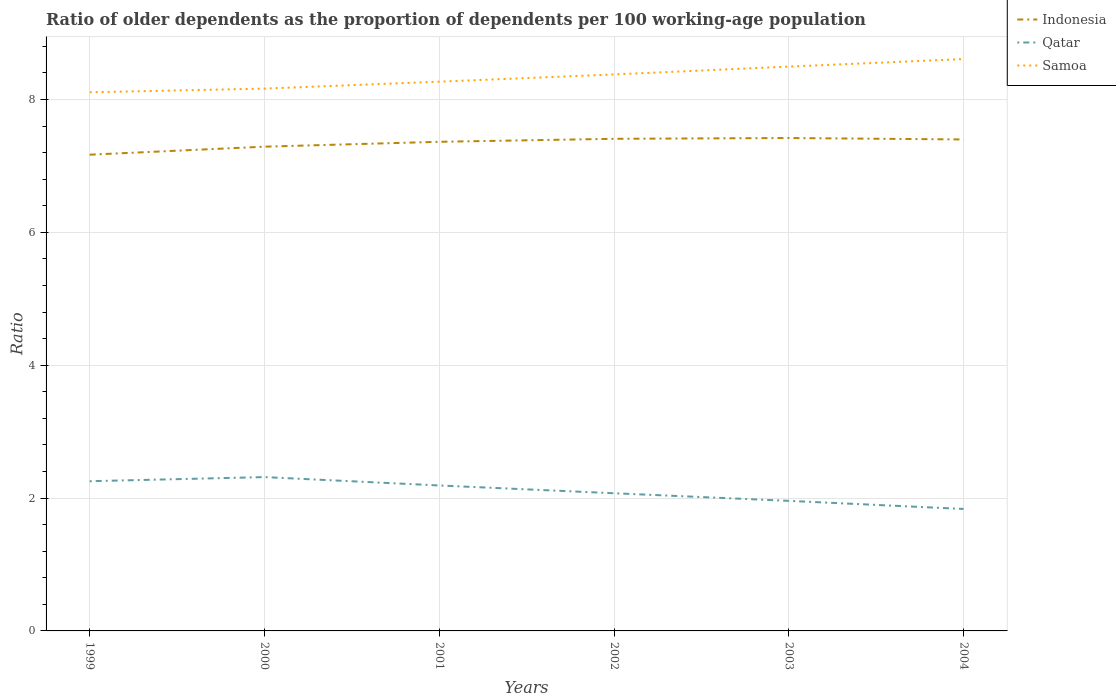Is the number of lines equal to the number of legend labels?
Your answer should be compact. Yes. Across all years, what is the maximum age dependency ratio(old) in Qatar?
Your answer should be compact. 1.84. What is the total age dependency ratio(old) in Indonesia in the graph?
Your answer should be very brief. -0.07. What is the difference between the highest and the second highest age dependency ratio(old) in Qatar?
Give a very brief answer. 0.48. What is the difference between the highest and the lowest age dependency ratio(old) in Samoa?
Offer a terse response. 3. Is the age dependency ratio(old) in Samoa strictly greater than the age dependency ratio(old) in Indonesia over the years?
Provide a succinct answer. No. How many lines are there?
Your answer should be compact. 3. Are the values on the major ticks of Y-axis written in scientific E-notation?
Make the answer very short. No. Does the graph contain grids?
Make the answer very short. Yes. How many legend labels are there?
Ensure brevity in your answer.  3. What is the title of the graph?
Ensure brevity in your answer.  Ratio of older dependents as the proportion of dependents per 100 working-age population. What is the label or title of the Y-axis?
Make the answer very short. Ratio. What is the Ratio of Indonesia in 1999?
Keep it short and to the point. 7.17. What is the Ratio of Qatar in 1999?
Your answer should be compact. 2.25. What is the Ratio of Samoa in 1999?
Give a very brief answer. 8.11. What is the Ratio in Indonesia in 2000?
Provide a succinct answer. 7.29. What is the Ratio of Qatar in 2000?
Provide a short and direct response. 2.32. What is the Ratio of Samoa in 2000?
Give a very brief answer. 8.16. What is the Ratio in Indonesia in 2001?
Give a very brief answer. 7.36. What is the Ratio in Qatar in 2001?
Ensure brevity in your answer.  2.19. What is the Ratio of Samoa in 2001?
Your answer should be compact. 8.27. What is the Ratio in Indonesia in 2002?
Offer a terse response. 7.41. What is the Ratio of Qatar in 2002?
Give a very brief answer. 2.07. What is the Ratio of Samoa in 2002?
Provide a short and direct response. 8.38. What is the Ratio in Indonesia in 2003?
Keep it short and to the point. 7.42. What is the Ratio in Qatar in 2003?
Keep it short and to the point. 1.96. What is the Ratio in Samoa in 2003?
Make the answer very short. 8.49. What is the Ratio in Indonesia in 2004?
Offer a very short reply. 7.4. What is the Ratio of Qatar in 2004?
Give a very brief answer. 1.84. What is the Ratio in Samoa in 2004?
Keep it short and to the point. 8.61. Across all years, what is the maximum Ratio of Indonesia?
Ensure brevity in your answer.  7.42. Across all years, what is the maximum Ratio in Qatar?
Offer a very short reply. 2.32. Across all years, what is the maximum Ratio in Samoa?
Provide a short and direct response. 8.61. Across all years, what is the minimum Ratio in Indonesia?
Your answer should be compact. 7.17. Across all years, what is the minimum Ratio in Qatar?
Your answer should be very brief. 1.84. Across all years, what is the minimum Ratio of Samoa?
Your response must be concise. 8.11. What is the total Ratio in Indonesia in the graph?
Keep it short and to the point. 44.05. What is the total Ratio in Qatar in the graph?
Provide a short and direct response. 12.62. What is the total Ratio of Samoa in the graph?
Ensure brevity in your answer.  50.02. What is the difference between the Ratio of Indonesia in 1999 and that in 2000?
Your response must be concise. -0.12. What is the difference between the Ratio of Qatar in 1999 and that in 2000?
Your answer should be compact. -0.06. What is the difference between the Ratio in Samoa in 1999 and that in 2000?
Provide a short and direct response. -0.06. What is the difference between the Ratio of Indonesia in 1999 and that in 2001?
Ensure brevity in your answer.  -0.19. What is the difference between the Ratio in Qatar in 1999 and that in 2001?
Your answer should be compact. 0.06. What is the difference between the Ratio in Samoa in 1999 and that in 2001?
Provide a short and direct response. -0.16. What is the difference between the Ratio of Indonesia in 1999 and that in 2002?
Keep it short and to the point. -0.24. What is the difference between the Ratio of Qatar in 1999 and that in 2002?
Keep it short and to the point. 0.18. What is the difference between the Ratio of Samoa in 1999 and that in 2002?
Make the answer very short. -0.27. What is the difference between the Ratio of Indonesia in 1999 and that in 2003?
Make the answer very short. -0.25. What is the difference between the Ratio of Qatar in 1999 and that in 2003?
Your response must be concise. 0.3. What is the difference between the Ratio in Samoa in 1999 and that in 2003?
Make the answer very short. -0.39. What is the difference between the Ratio in Indonesia in 1999 and that in 2004?
Offer a terse response. -0.23. What is the difference between the Ratio in Qatar in 1999 and that in 2004?
Your response must be concise. 0.42. What is the difference between the Ratio of Samoa in 1999 and that in 2004?
Give a very brief answer. -0.5. What is the difference between the Ratio in Indonesia in 2000 and that in 2001?
Provide a succinct answer. -0.07. What is the difference between the Ratio in Qatar in 2000 and that in 2001?
Provide a succinct answer. 0.13. What is the difference between the Ratio in Samoa in 2000 and that in 2001?
Offer a terse response. -0.1. What is the difference between the Ratio in Indonesia in 2000 and that in 2002?
Your answer should be very brief. -0.12. What is the difference between the Ratio of Qatar in 2000 and that in 2002?
Offer a very short reply. 0.24. What is the difference between the Ratio in Samoa in 2000 and that in 2002?
Give a very brief answer. -0.21. What is the difference between the Ratio of Indonesia in 2000 and that in 2003?
Give a very brief answer. -0.13. What is the difference between the Ratio in Qatar in 2000 and that in 2003?
Ensure brevity in your answer.  0.36. What is the difference between the Ratio in Samoa in 2000 and that in 2003?
Offer a terse response. -0.33. What is the difference between the Ratio in Indonesia in 2000 and that in 2004?
Ensure brevity in your answer.  -0.11. What is the difference between the Ratio of Qatar in 2000 and that in 2004?
Your answer should be very brief. 0.48. What is the difference between the Ratio of Samoa in 2000 and that in 2004?
Give a very brief answer. -0.44. What is the difference between the Ratio in Indonesia in 2001 and that in 2002?
Give a very brief answer. -0.05. What is the difference between the Ratio in Qatar in 2001 and that in 2002?
Your response must be concise. 0.12. What is the difference between the Ratio in Samoa in 2001 and that in 2002?
Ensure brevity in your answer.  -0.11. What is the difference between the Ratio in Indonesia in 2001 and that in 2003?
Ensure brevity in your answer.  -0.06. What is the difference between the Ratio in Qatar in 2001 and that in 2003?
Ensure brevity in your answer.  0.23. What is the difference between the Ratio in Samoa in 2001 and that in 2003?
Your response must be concise. -0.23. What is the difference between the Ratio in Indonesia in 2001 and that in 2004?
Your answer should be very brief. -0.04. What is the difference between the Ratio of Qatar in 2001 and that in 2004?
Make the answer very short. 0.35. What is the difference between the Ratio of Samoa in 2001 and that in 2004?
Offer a terse response. -0.34. What is the difference between the Ratio in Indonesia in 2002 and that in 2003?
Your answer should be compact. -0.01. What is the difference between the Ratio of Qatar in 2002 and that in 2003?
Give a very brief answer. 0.11. What is the difference between the Ratio in Samoa in 2002 and that in 2003?
Provide a short and direct response. -0.12. What is the difference between the Ratio in Indonesia in 2002 and that in 2004?
Your answer should be compact. 0.01. What is the difference between the Ratio in Qatar in 2002 and that in 2004?
Provide a succinct answer. 0.24. What is the difference between the Ratio in Samoa in 2002 and that in 2004?
Offer a very short reply. -0.23. What is the difference between the Ratio in Indonesia in 2003 and that in 2004?
Give a very brief answer. 0.02. What is the difference between the Ratio in Qatar in 2003 and that in 2004?
Provide a short and direct response. 0.12. What is the difference between the Ratio of Samoa in 2003 and that in 2004?
Ensure brevity in your answer.  -0.11. What is the difference between the Ratio of Indonesia in 1999 and the Ratio of Qatar in 2000?
Your response must be concise. 4.85. What is the difference between the Ratio of Indonesia in 1999 and the Ratio of Samoa in 2000?
Offer a very short reply. -0.99. What is the difference between the Ratio of Qatar in 1999 and the Ratio of Samoa in 2000?
Offer a very short reply. -5.91. What is the difference between the Ratio of Indonesia in 1999 and the Ratio of Qatar in 2001?
Ensure brevity in your answer.  4.98. What is the difference between the Ratio of Indonesia in 1999 and the Ratio of Samoa in 2001?
Provide a short and direct response. -1.1. What is the difference between the Ratio in Qatar in 1999 and the Ratio in Samoa in 2001?
Keep it short and to the point. -6.01. What is the difference between the Ratio of Indonesia in 1999 and the Ratio of Qatar in 2002?
Your response must be concise. 5.1. What is the difference between the Ratio of Indonesia in 1999 and the Ratio of Samoa in 2002?
Your answer should be very brief. -1.21. What is the difference between the Ratio of Qatar in 1999 and the Ratio of Samoa in 2002?
Your answer should be compact. -6.12. What is the difference between the Ratio in Indonesia in 1999 and the Ratio in Qatar in 2003?
Make the answer very short. 5.21. What is the difference between the Ratio in Indonesia in 1999 and the Ratio in Samoa in 2003?
Ensure brevity in your answer.  -1.33. What is the difference between the Ratio in Qatar in 1999 and the Ratio in Samoa in 2003?
Provide a succinct answer. -6.24. What is the difference between the Ratio of Indonesia in 1999 and the Ratio of Qatar in 2004?
Keep it short and to the point. 5.33. What is the difference between the Ratio in Indonesia in 1999 and the Ratio in Samoa in 2004?
Offer a terse response. -1.44. What is the difference between the Ratio of Qatar in 1999 and the Ratio of Samoa in 2004?
Ensure brevity in your answer.  -6.35. What is the difference between the Ratio of Indonesia in 2000 and the Ratio of Qatar in 2001?
Your response must be concise. 5.1. What is the difference between the Ratio in Indonesia in 2000 and the Ratio in Samoa in 2001?
Your answer should be very brief. -0.98. What is the difference between the Ratio in Qatar in 2000 and the Ratio in Samoa in 2001?
Keep it short and to the point. -5.95. What is the difference between the Ratio in Indonesia in 2000 and the Ratio in Qatar in 2002?
Your answer should be compact. 5.22. What is the difference between the Ratio of Indonesia in 2000 and the Ratio of Samoa in 2002?
Offer a terse response. -1.09. What is the difference between the Ratio in Qatar in 2000 and the Ratio in Samoa in 2002?
Provide a succinct answer. -6.06. What is the difference between the Ratio of Indonesia in 2000 and the Ratio of Qatar in 2003?
Provide a succinct answer. 5.33. What is the difference between the Ratio in Indonesia in 2000 and the Ratio in Samoa in 2003?
Your answer should be very brief. -1.21. What is the difference between the Ratio of Qatar in 2000 and the Ratio of Samoa in 2003?
Provide a succinct answer. -6.18. What is the difference between the Ratio of Indonesia in 2000 and the Ratio of Qatar in 2004?
Your response must be concise. 5.45. What is the difference between the Ratio of Indonesia in 2000 and the Ratio of Samoa in 2004?
Give a very brief answer. -1.32. What is the difference between the Ratio in Qatar in 2000 and the Ratio in Samoa in 2004?
Make the answer very short. -6.29. What is the difference between the Ratio in Indonesia in 2001 and the Ratio in Qatar in 2002?
Ensure brevity in your answer.  5.29. What is the difference between the Ratio in Indonesia in 2001 and the Ratio in Samoa in 2002?
Provide a succinct answer. -1.01. What is the difference between the Ratio of Qatar in 2001 and the Ratio of Samoa in 2002?
Provide a short and direct response. -6.19. What is the difference between the Ratio of Indonesia in 2001 and the Ratio of Qatar in 2003?
Ensure brevity in your answer.  5.4. What is the difference between the Ratio in Indonesia in 2001 and the Ratio in Samoa in 2003?
Provide a succinct answer. -1.13. What is the difference between the Ratio in Qatar in 2001 and the Ratio in Samoa in 2003?
Ensure brevity in your answer.  -6.31. What is the difference between the Ratio in Indonesia in 2001 and the Ratio in Qatar in 2004?
Provide a succinct answer. 5.53. What is the difference between the Ratio in Indonesia in 2001 and the Ratio in Samoa in 2004?
Offer a terse response. -1.25. What is the difference between the Ratio of Qatar in 2001 and the Ratio of Samoa in 2004?
Provide a short and direct response. -6.42. What is the difference between the Ratio in Indonesia in 2002 and the Ratio in Qatar in 2003?
Your answer should be very brief. 5.45. What is the difference between the Ratio of Indonesia in 2002 and the Ratio of Samoa in 2003?
Keep it short and to the point. -1.09. What is the difference between the Ratio of Qatar in 2002 and the Ratio of Samoa in 2003?
Offer a very short reply. -6.42. What is the difference between the Ratio in Indonesia in 2002 and the Ratio in Qatar in 2004?
Your response must be concise. 5.57. What is the difference between the Ratio in Indonesia in 2002 and the Ratio in Samoa in 2004?
Keep it short and to the point. -1.2. What is the difference between the Ratio of Qatar in 2002 and the Ratio of Samoa in 2004?
Offer a terse response. -6.54. What is the difference between the Ratio in Indonesia in 2003 and the Ratio in Qatar in 2004?
Ensure brevity in your answer.  5.58. What is the difference between the Ratio in Indonesia in 2003 and the Ratio in Samoa in 2004?
Provide a short and direct response. -1.19. What is the difference between the Ratio in Qatar in 2003 and the Ratio in Samoa in 2004?
Offer a terse response. -6.65. What is the average Ratio in Indonesia per year?
Make the answer very short. 7.34. What is the average Ratio of Qatar per year?
Provide a short and direct response. 2.1. What is the average Ratio of Samoa per year?
Offer a very short reply. 8.34. In the year 1999, what is the difference between the Ratio of Indonesia and Ratio of Qatar?
Keep it short and to the point. 4.92. In the year 1999, what is the difference between the Ratio of Indonesia and Ratio of Samoa?
Your response must be concise. -0.94. In the year 1999, what is the difference between the Ratio in Qatar and Ratio in Samoa?
Ensure brevity in your answer.  -5.85. In the year 2000, what is the difference between the Ratio of Indonesia and Ratio of Qatar?
Ensure brevity in your answer.  4.97. In the year 2000, what is the difference between the Ratio of Indonesia and Ratio of Samoa?
Keep it short and to the point. -0.87. In the year 2000, what is the difference between the Ratio of Qatar and Ratio of Samoa?
Your answer should be compact. -5.85. In the year 2001, what is the difference between the Ratio in Indonesia and Ratio in Qatar?
Keep it short and to the point. 5.17. In the year 2001, what is the difference between the Ratio of Indonesia and Ratio of Samoa?
Give a very brief answer. -0.91. In the year 2001, what is the difference between the Ratio of Qatar and Ratio of Samoa?
Your answer should be compact. -6.08. In the year 2002, what is the difference between the Ratio of Indonesia and Ratio of Qatar?
Your answer should be compact. 5.34. In the year 2002, what is the difference between the Ratio of Indonesia and Ratio of Samoa?
Keep it short and to the point. -0.97. In the year 2002, what is the difference between the Ratio in Qatar and Ratio in Samoa?
Provide a short and direct response. -6.3. In the year 2003, what is the difference between the Ratio of Indonesia and Ratio of Qatar?
Keep it short and to the point. 5.46. In the year 2003, what is the difference between the Ratio in Indonesia and Ratio in Samoa?
Your answer should be compact. -1.08. In the year 2003, what is the difference between the Ratio of Qatar and Ratio of Samoa?
Your answer should be very brief. -6.54. In the year 2004, what is the difference between the Ratio of Indonesia and Ratio of Qatar?
Provide a short and direct response. 5.56. In the year 2004, what is the difference between the Ratio of Indonesia and Ratio of Samoa?
Offer a terse response. -1.21. In the year 2004, what is the difference between the Ratio in Qatar and Ratio in Samoa?
Provide a short and direct response. -6.77. What is the ratio of the Ratio in Indonesia in 1999 to that in 2000?
Make the answer very short. 0.98. What is the ratio of the Ratio in Qatar in 1999 to that in 2000?
Your answer should be very brief. 0.97. What is the ratio of the Ratio of Indonesia in 1999 to that in 2001?
Make the answer very short. 0.97. What is the ratio of the Ratio of Qatar in 1999 to that in 2001?
Make the answer very short. 1.03. What is the ratio of the Ratio in Samoa in 1999 to that in 2001?
Your response must be concise. 0.98. What is the ratio of the Ratio in Qatar in 1999 to that in 2002?
Provide a succinct answer. 1.09. What is the ratio of the Ratio of Samoa in 1999 to that in 2002?
Ensure brevity in your answer.  0.97. What is the ratio of the Ratio in Indonesia in 1999 to that in 2003?
Offer a very short reply. 0.97. What is the ratio of the Ratio of Qatar in 1999 to that in 2003?
Offer a very short reply. 1.15. What is the ratio of the Ratio of Samoa in 1999 to that in 2003?
Your answer should be compact. 0.95. What is the ratio of the Ratio in Qatar in 1999 to that in 2004?
Provide a succinct answer. 1.23. What is the ratio of the Ratio in Samoa in 1999 to that in 2004?
Ensure brevity in your answer.  0.94. What is the ratio of the Ratio in Indonesia in 2000 to that in 2001?
Your answer should be compact. 0.99. What is the ratio of the Ratio in Qatar in 2000 to that in 2001?
Keep it short and to the point. 1.06. What is the ratio of the Ratio in Samoa in 2000 to that in 2001?
Ensure brevity in your answer.  0.99. What is the ratio of the Ratio in Qatar in 2000 to that in 2002?
Your answer should be compact. 1.12. What is the ratio of the Ratio of Samoa in 2000 to that in 2002?
Keep it short and to the point. 0.97. What is the ratio of the Ratio of Indonesia in 2000 to that in 2003?
Keep it short and to the point. 0.98. What is the ratio of the Ratio in Qatar in 2000 to that in 2003?
Your answer should be compact. 1.18. What is the ratio of the Ratio in Qatar in 2000 to that in 2004?
Keep it short and to the point. 1.26. What is the ratio of the Ratio in Samoa in 2000 to that in 2004?
Provide a short and direct response. 0.95. What is the ratio of the Ratio of Qatar in 2001 to that in 2002?
Offer a terse response. 1.06. What is the ratio of the Ratio in Samoa in 2001 to that in 2002?
Your answer should be compact. 0.99. What is the ratio of the Ratio in Indonesia in 2001 to that in 2003?
Ensure brevity in your answer.  0.99. What is the ratio of the Ratio in Qatar in 2001 to that in 2003?
Offer a very short reply. 1.12. What is the ratio of the Ratio in Samoa in 2001 to that in 2003?
Your answer should be compact. 0.97. What is the ratio of the Ratio of Indonesia in 2001 to that in 2004?
Offer a terse response. 1. What is the ratio of the Ratio in Qatar in 2001 to that in 2004?
Your response must be concise. 1.19. What is the ratio of the Ratio in Samoa in 2001 to that in 2004?
Offer a terse response. 0.96. What is the ratio of the Ratio in Qatar in 2002 to that in 2003?
Provide a short and direct response. 1.06. What is the ratio of the Ratio of Samoa in 2002 to that in 2003?
Your response must be concise. 0.99. What is the ratio of the Ratio in Indonesia in 2002 to that in 2004?
Make the answer very short. 1. What is the ratio of the Ratio in Qatar in 2002 to that in 2004?
Your response must be concise. 1.13. What is the ratio of the Ratio in Samoa in 2002 to that in 2004?
Offer a terse response. 0.97. What is the ratio of the Ratio in Indonesia in 2003 to that in 2004?
Give a very brief answer. 1. What is the ratio of the Ratio in Qatar in 2003 to that in 2004?
Keep it short and to the point. 1.07. What is the ratio of the Ratio of Samoa in 2003 to that in 2004?
Your answer should be compact. 0.99. What is the difference between the highest and the second highest Ratio in Indonesia?
Ensure brevity in your answer.  0.01. What is the difference between the highest and the second highest Ratio in Qatar?
Your response must be concise. 0.06. What is the difference between the highest and the second highest Ratio of Samoa?
Offer a terse response. 0.11. What is the difference between the highest and the lowest Ratio of Indonesia?
Your response must be concise. 0.25. What is the difference between the highest and the lowest Ratio of Qatar?
Your answer should be very brief. 0.48. What is the difference between the highest and the lowest Ratio of Samoa?
Provide a succinct answer. 0.5. 